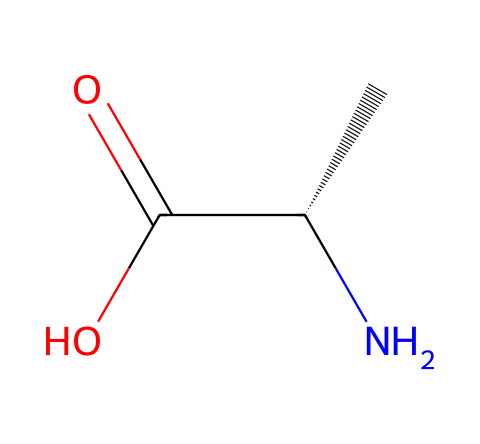What is the molecular formula for this compound? The SMILES representation shows a molecule with carbon (C), hydrogen (H), nitrogen (N), and oxygen (O). By counting the atoms, we see 2 carbons, 5 hydrogens, 1 nitrogen, and 2 oxygens, leading to the molecular formula C2H5NO2.
Answer: C2H5NO2 How many total atoms are present in this structure? Counting the individual atoms listed in the molecular formula (C2H5NO2), we find 2 carbon atoms, 5 hydrogen atoms, 1 nitrogen atom, and 2 oxygen atoms, which sums up to 10 total atoms.
Answer: 10 What functional groups are present in this molecule? The structure contains a carboxylic acid group (-COOH, seen with the C(=O)O) and an amino group (-NH2, seen with the N atom in C[C@H](N)). These groups classify this compound as an amino acid.
Answer: carboxylic acid and amino group What is the significance of the amino group in this compound? The amino group allows the compound to serve as a building block for proteins and plays a role in metabolic pathways such as gluconeogenesis, where it can affect blood sugar levels.
Answer: amino acid building block How does the presence of the carboxylic acid group affect the molecule's properties? The carboxylic acid group contributes to the molecule's acidity and solubility in water, making it highly reactive in various biochemical reactions including those involved in blood sugar regulation.
Answer: increases acidity and solubility How many chiral centers are present in this compound? Analyzing the carbon atoms in this compound, the carbon attached to the amino group is a chiral center since it has four different substituents (an amino group, a carboxylic group, a hydrogen, and another carbon). Therefore, it has 1 chiral center.
Answer: 1 What role does this molecule play in blood sugar regulation? This compound, known as an amino acid, can act as a precursor for the synthesis of insulin, which is crucial in regulating blood sugar levels by facilitating glucose uptake in tissues.
Answer: precursor for insulin 